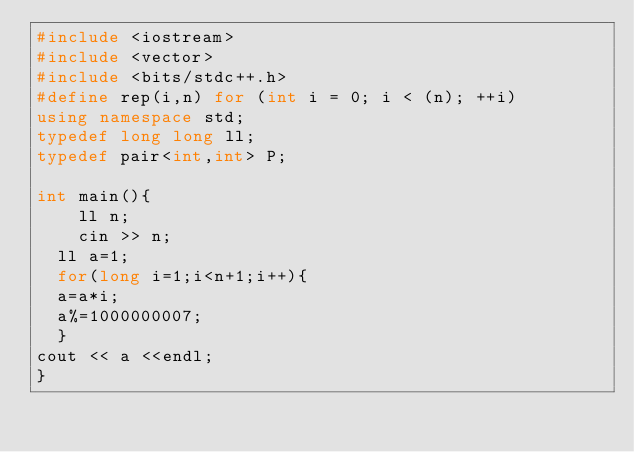<code> <loc_0><loc_0><loc_500><loc_500><_C++_>#include <iostream>
#include <vector>
#include <bits/stdc++.h>
#define rep(i,n) for (int i = 0; i < (n); ++i)
using namespace std;
typedef long long ll;
typedef pair<int,int> P;

int main(){
    ll n;
    cin >> n;
  ll a=1;
  for(long i=1;i<n+1;i++){
  a=a*i;
  a%=1000000007;
  }
cout << a <<endl;
}</code> 